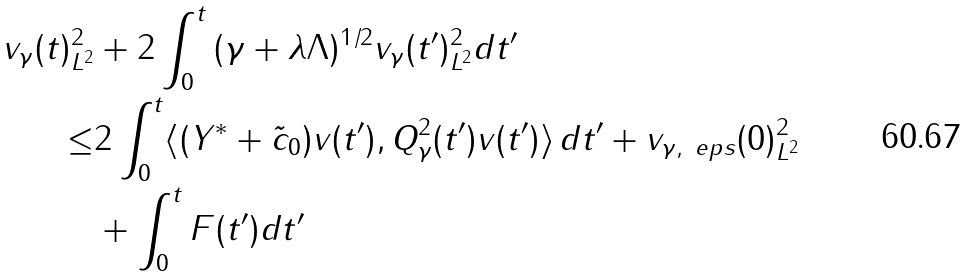<formula> <loc_0><loc_0><loc_500><loc_500>\| v _ { \gamma } ( t ) \| ^ { 2 } _ { L ^ { 2 } } & + 2 \int _ { 0 } ^ { t } \| ( \gamma + \lambda \Lambda ) ^ { 1 / 2 } v _ { \gamma } ( t ^ { \prime } ) \| ^ { 2 } _ { L ^ { 2 } } d t ^ { \prime } \\ \leq & 2 \int _ { 0 } ^ { t } \langle ( Y ^ { * } + \tilde { c } _ { 0 } ) v ( t ^ { \prime } ) , Q _ { \gamma } ^ { 2 } ( t ^ { \prime } ) v ( t ^ { \prime } ) \rangle \, d t ^ { \prime } + \| v _ { \gamma , \ e p s } ( 0 ) \| ^ { 2 } _ { L ^ { 2 } } \\ & + \int _ { 0 } ^ { t } F ( t ^ { \prime } ) d t ^ { \prime }</formula> 